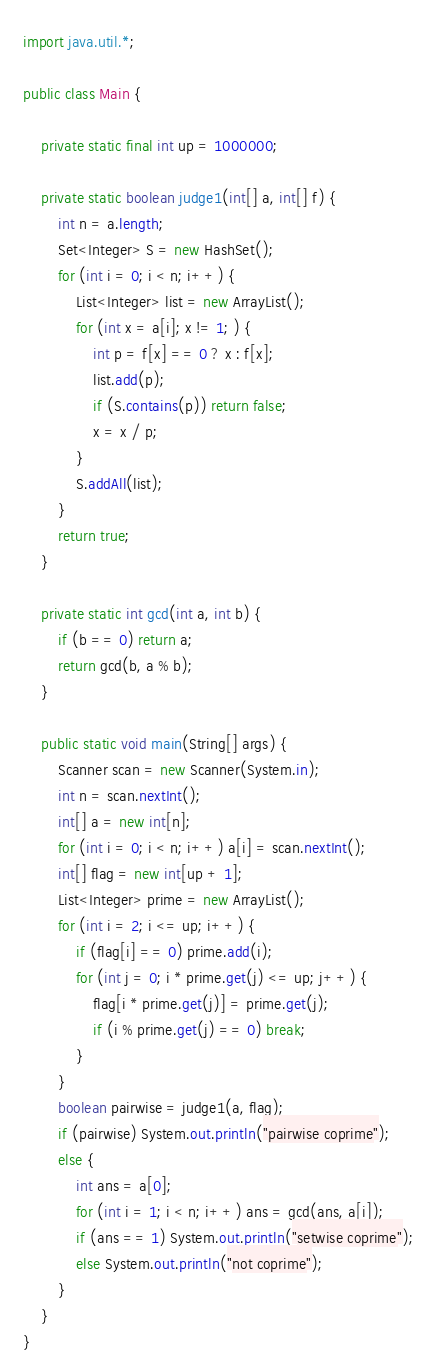Convert code to text. <code><loc_0><loc_0><loc_500><loc_500><_Java_>import java.util.*;

public class Main {

    private static final int up = 1000000;

    private static boolean judge1(int[] a, int[] f) {
        int n = a.length;
        Set<Integer> S = new HashSet();
        for (int i = 0; i < n; i++) {
            List<Integer> list = new ArrayList();
            for (int x = a[i]; x != 1; ) {
                int p = f[x] == 0 ? x : f[x];
                list.add(p);
                if (S.contains(p)) return false;
                x = x / p;
            }
            S.addAll(list);
        }
        return true;
    }

    private static int gcd(int a, int b) {
        if (b == 0) return a;
        return gcd(b, a % b);
    }

    public static void main(String[] args) {
        Scanner scan = new Scanner(System.in);
        int n = scan.nextInt();
        int[] a = new int[n];
        for (int i = 0; i < n; i++) a[i] = scan.nextInt();
        int[] flag = new int[up + 1];
        List<Integer> prime = new ArrayList();
        for (int i = 2; i <= up; i++) {
            if (flag[i] == 0) prime.add(i);
            for (int j = 0; i * prime.get(j) <= up; j++) {
                flag[i * prime.get(j)] = prime.get(j);
                if (i % prime.get(j) == 0) break;
            }
        }
        boolean pairwise = judge1(a, flag);
        if (pairwise) System.out.println("pairwise coprime");
        else {
            int ans = a[0];
            for (int i = 1; i < n; i++) ans = gcd(ans, a[i]);
            if (ans == 1) System.out.println("setwise coprime");
            else System.out.println("not coprime");
        }
    }
}
</code> 